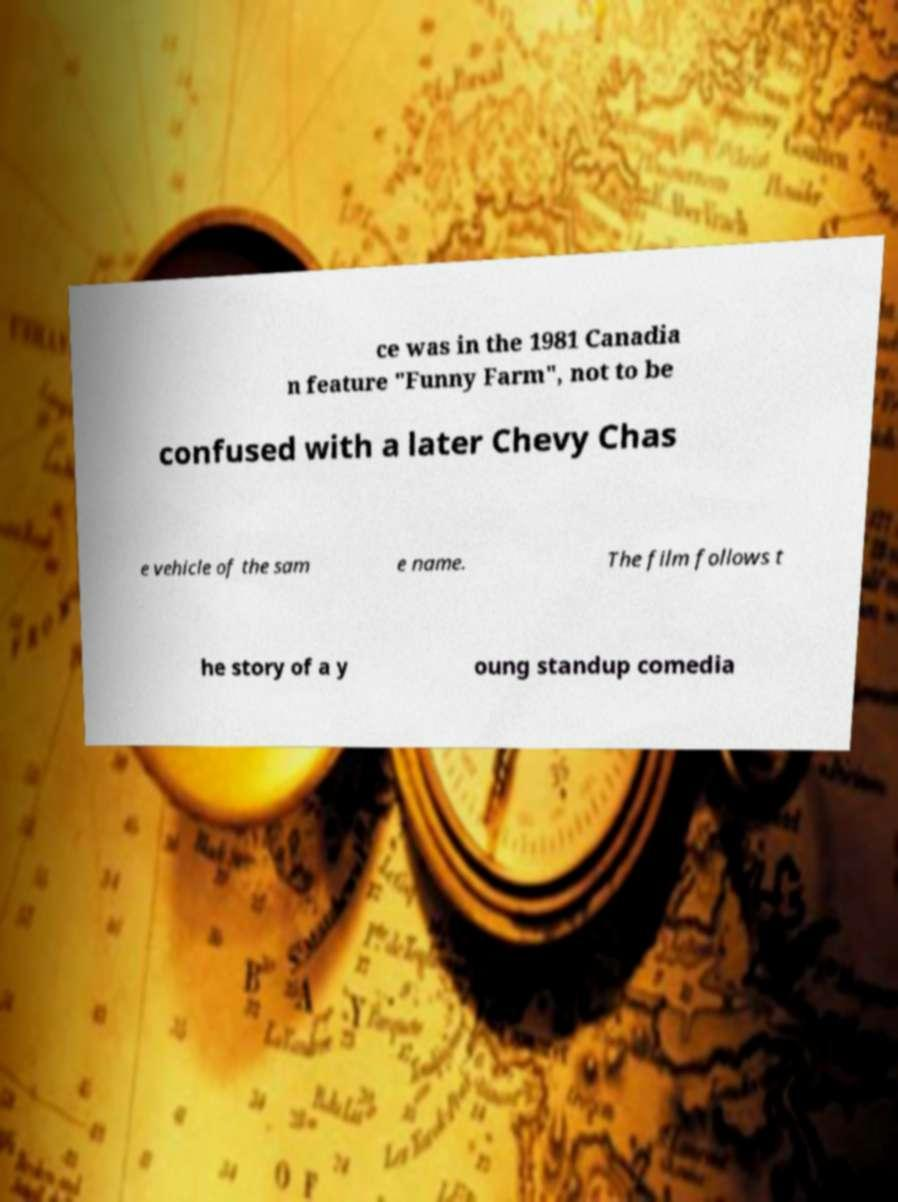There's text embedded in this image that I need extracted. Can you transcribe it verbatim? ce was in the 1981 Canadia n feature "Funny Farm", not to be confused with a later Chevy Chas e vehicle of the sam e name. The film follows t he story of a y oung standup comedia 